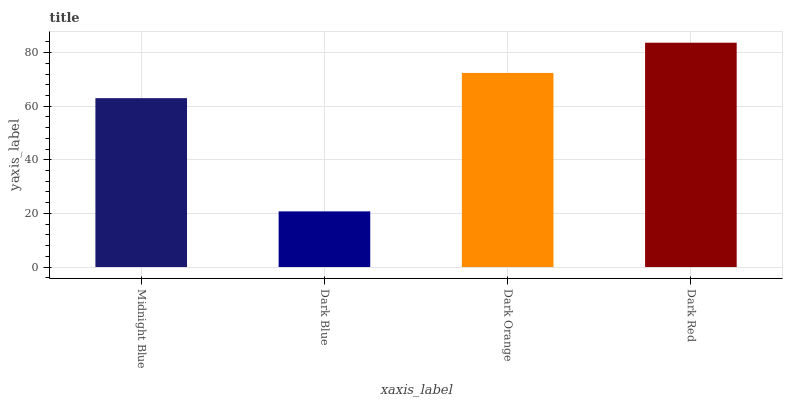Is Dark Blue the minimum?
Answer yes or no. Yes. Is Dark Red the maximum?
Answer yes or no. Yes. Is Dark Orange the minimum?
Answer yes or no. No. Is Dark Orange the maximum?
Answer yes or no. No. Is Dark Orange greater than Dark Blue?
Answer yes or no. Yes. Is Dark Blue less than Dark Orange?
Answer yes or no. Yes. Is Dark Blue greater than Dark Orange?
Answer yes or no. No. Is Dark Orange less than Dark Blue?
Answer yes or no. No. Is Dark Orange the high median?
Answer yes or no. Yes. Is Midnight Blue the low median?
Answer yes or no. Yes. Is Dark Blue the high median?
Answer yes or no. No. Is Dark Orange the low median?
Answer yes or no. No. 